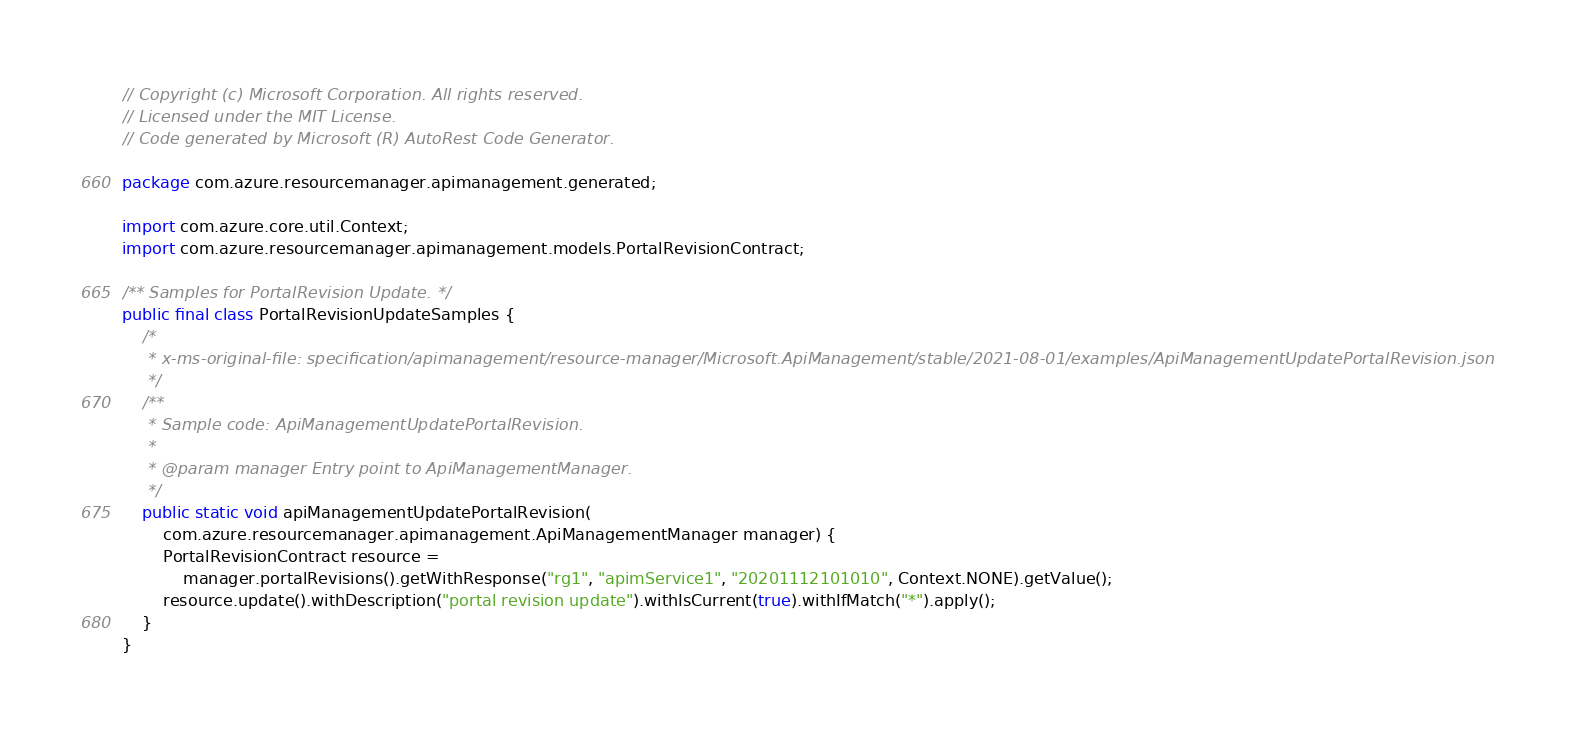<code> <loc_0><loc_0><loc_500><loc_500><_Java_>// Copyright (c) Microsoft Corporation. All rights reserved.
// Licensed under the MIT License.
// Code generated by Microsoft (R) AutoRest Code Generator.

package com.azure.resourcemanager.apimanagement.generated;

import com.azure.core.util.Context;
import com.azure.resourcemanager.apimanagement.models.PortalRevisionContract;

/** Samples for PortalRevision Update. */
public final class PortalRevisionUpdateSamples {
    /*
     * x-ms-original-file: specification/apimanagement/resource-manager/Microsoft.ApiManagement/stable/2021-08-01/examples/ApiManagementUpdatePortalRevision.json
     */
    /**
     * Sample code: ApiManagementUpdatePortalRevision.
     *
     * @param manager Entry point to ApiManagementManager.
     */
    public static void apiManagementUpdatePortalRevision(
        com.azure.resourcemanager.apimanagement.ApiManagementManager manager) {
        PortalRevisionContract resource =
            manager.portalRevisions().getWithResponse("rg1", "apimService1", "20201112101010", Context.NONE).getValue();
        resource.update().withDescription("portal revision update").withIsCurrent(true).withIfMatch("*").apply();
    }
}
</code> 